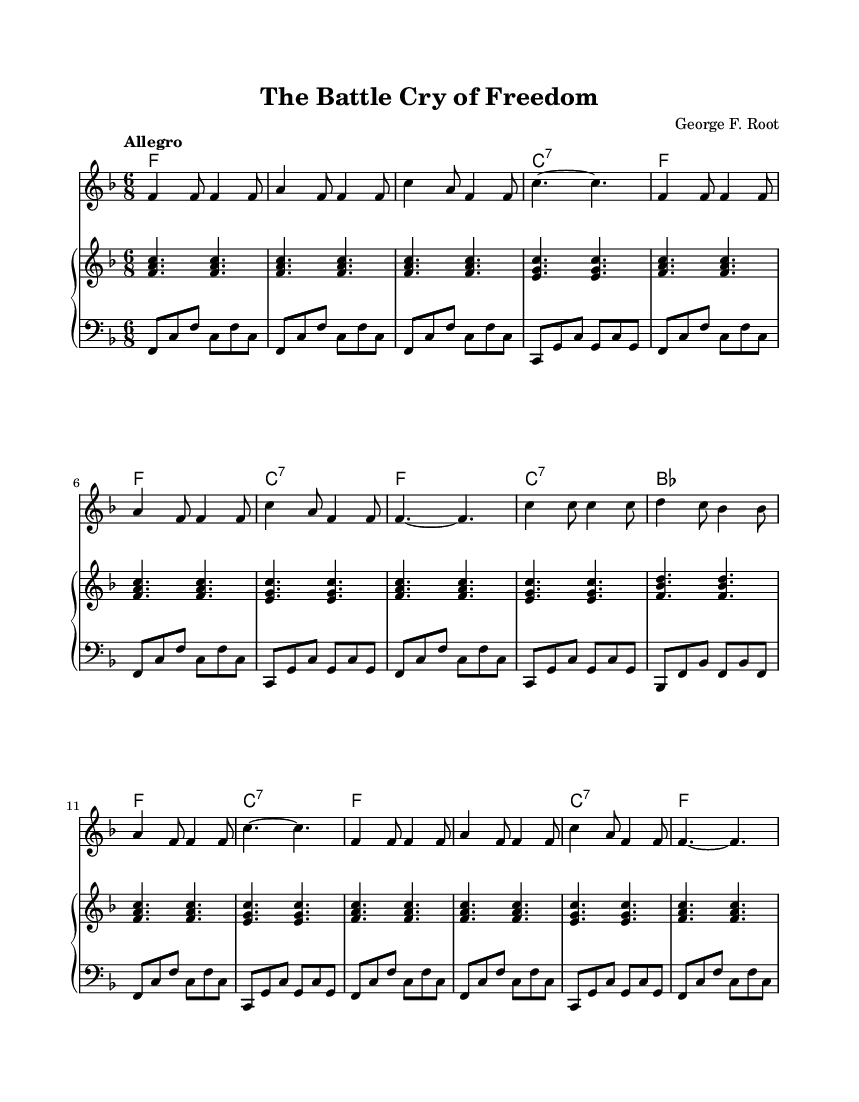What is the title of the song? The title is prominently indicated in the header section of the music.
Answer: The Battle Cry of Freedom What is the composer of the song? The composer is listed in the header section of the music next to the title.
Answer: George F. Root What is the time signature of this music? The time signature is found in the global section, which states it is in 6/8 time.
Answer: 6/8 What is the key signature of this music? The key signature is also in the global section, which indicates it is in F major (one flat).
Answer: F major How many measures are there in the melody? Counting the measures within the melody section reveals there are 14 measures in total.
Answer: 14 What broader historical theme does this song depict? The theme can be derived from the song's title and lyrics, which refer to freedom and rallying, indicative of the context of the American Civil War.
Answer: American Civil War What is the tempo marking of the song? The tempo is noted in the global section of the score, which is described as "Allegro."
Answer: Allegro 